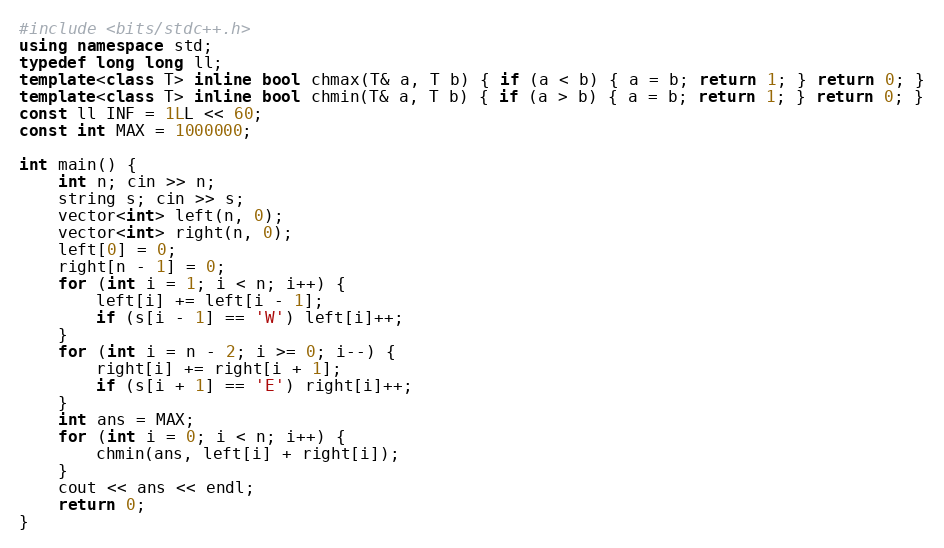<code> <loc_0><loc_0><loc_500><loc_500><_C++_>#include <bits/stdc++.h>
using namespace std;
typedef long long ll;
template<class T> inline bool chmax(T& a, T b) { if (a < b) { a = b; return 1; } return 0; }
template<class T> inline bool chmin(T& a, T b) { if (a > b) { a = b; return 1; } return 0; }
const ll INF = 1LL << 60;
const int MAX = 1000000;

int main() {
    int n; cin >> n;
    string s; cin >> s;
    vector<int> left(n, 0);
    vector<int> right(n, 0);
    left[0] = 0;
    right[n - 1] = 0;
    for (int i = 1; i < n; i++) {
        left[i] += left[i - 1];
        if (s[i - 1] == 'W') left[i]++;
    }
    for (int i = n - 2; i >= 0; i--) {
        right[i] += right[i + 1];
        if (s[i + 1] == 'E') right[i]++;
    }
    int ans = MAX;
    for (int i = 0; i < n; i++) {
        chmin(ans, left[i] + right[i]);
    }
    cout << ans << endl;
    return 0;
}</code> 